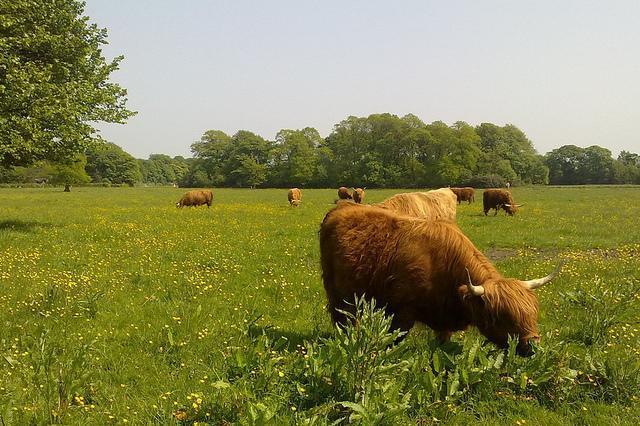How many animals?
Give a very brief answer. 8. 